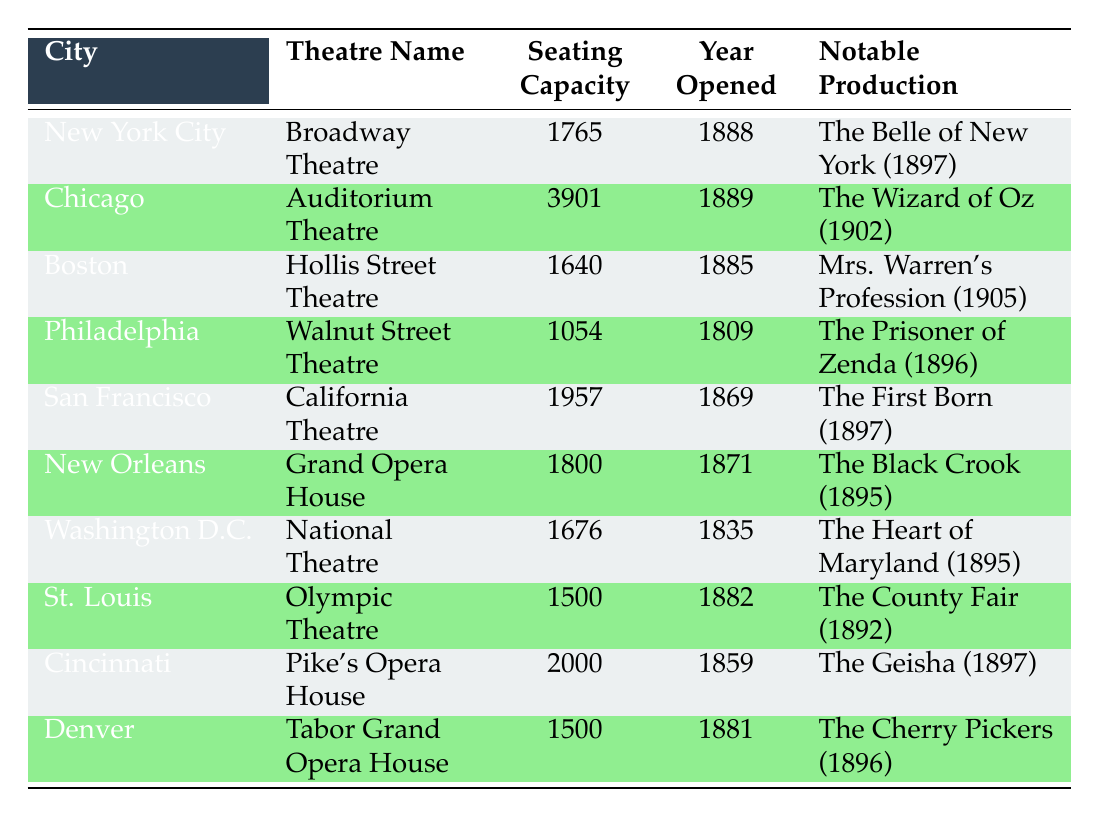What is the seating capacity of the Auditorium Theatre in Chicago? The table indicates that the seating capacity of the Auditorium Theatre is listed directly in the "Seating Capacity" column next to Chicago. Therefore, we simply look up that value.
Answer: 3901 Which theatre has the oldest opening year? To determine which theatre opened first, we can examine the "Year Opened" column. The oldest year in this column is 1809, which corresponds to the Walnut Street Theatre in Philadelphia.
Answer: Walnut Street Theatre How many theatres have a seating capacity of at least 1500? We review the "Seating Capacity" column and count the number of theatres that meet the criteria of having a capacity of at least 1500. The relevant theatres are: Auditorium Theatre (3901), California Theatre (1957), Grand Opera House (1800), Olympic Theatre (1500), Pike's Opera House (2000), and Tabor Grand Opera House (1500), making a total of 6 theatres.
Answer: 6 What is the average seating capacity of the theatres listed in the table? To find the average, we first calculate the total seating capacity by adding the values from the "Seating Capacity" column: 1765 + 3901 + 1640 + 1054 + 1957 + 1800 + 1676 + 1500 + 2000 + 1500 = 11853. Then, we divide by the number of theatres (10), which gives us 11853 / 10 = 1185.3. Thus, the average seating capacity is approximately 1185.3.
Answer: 1185.3 Is The Wizard of Oz noted as a production in any theatre within the 1890s timeframe listed in the table? By scanning the "Notable Production" column, we find that The Wizard of Oz was produced in the Auditorium Theatre, which opened in 1889 but is noted for the performance occurring in 1902, which is outside the 1890s. Therefore, it is not counted within the 1890s timeframe.
Answer: No Which city has both a notable production that premiered in 1895 and a theatre opened before 1900? We search for cities that have notable productions from 1895 listed in the "Notable Production" column. New Orleans (Grand Opera House) and Washington D.C. (National Theatre) fit this criterion as both theatres opened in 1871 and 1835, respectively. Therefore, they satisfy both conditions.
Answer: New Orleans and Washington D.C 